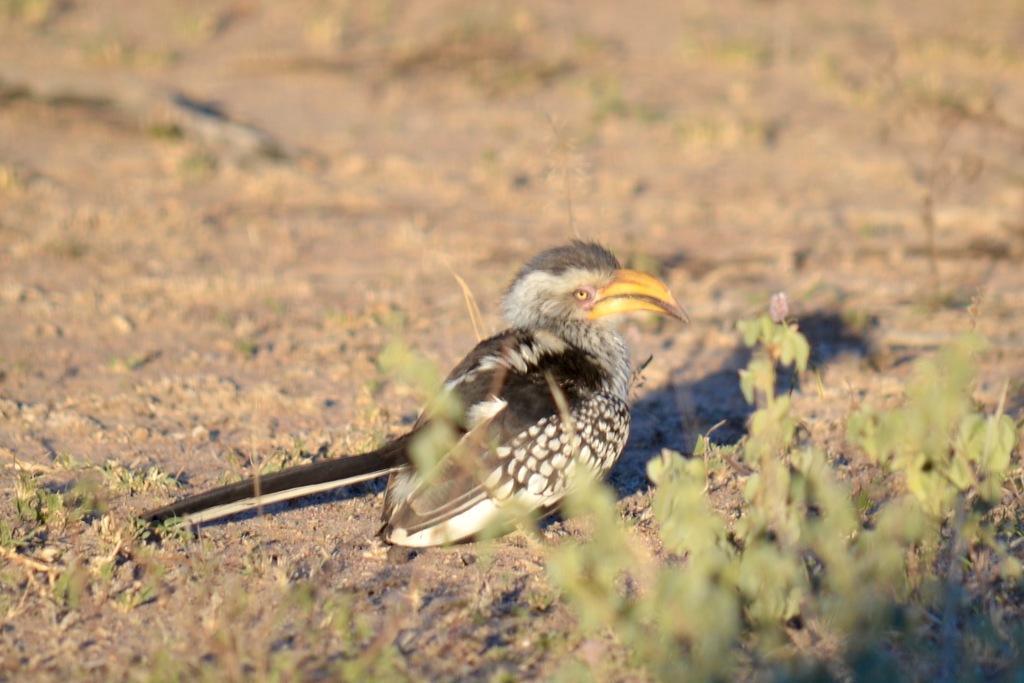Could you give a brief overview of what you see in this image? In the image in the center, we can see one plant and one bird, which is in black and white color. 